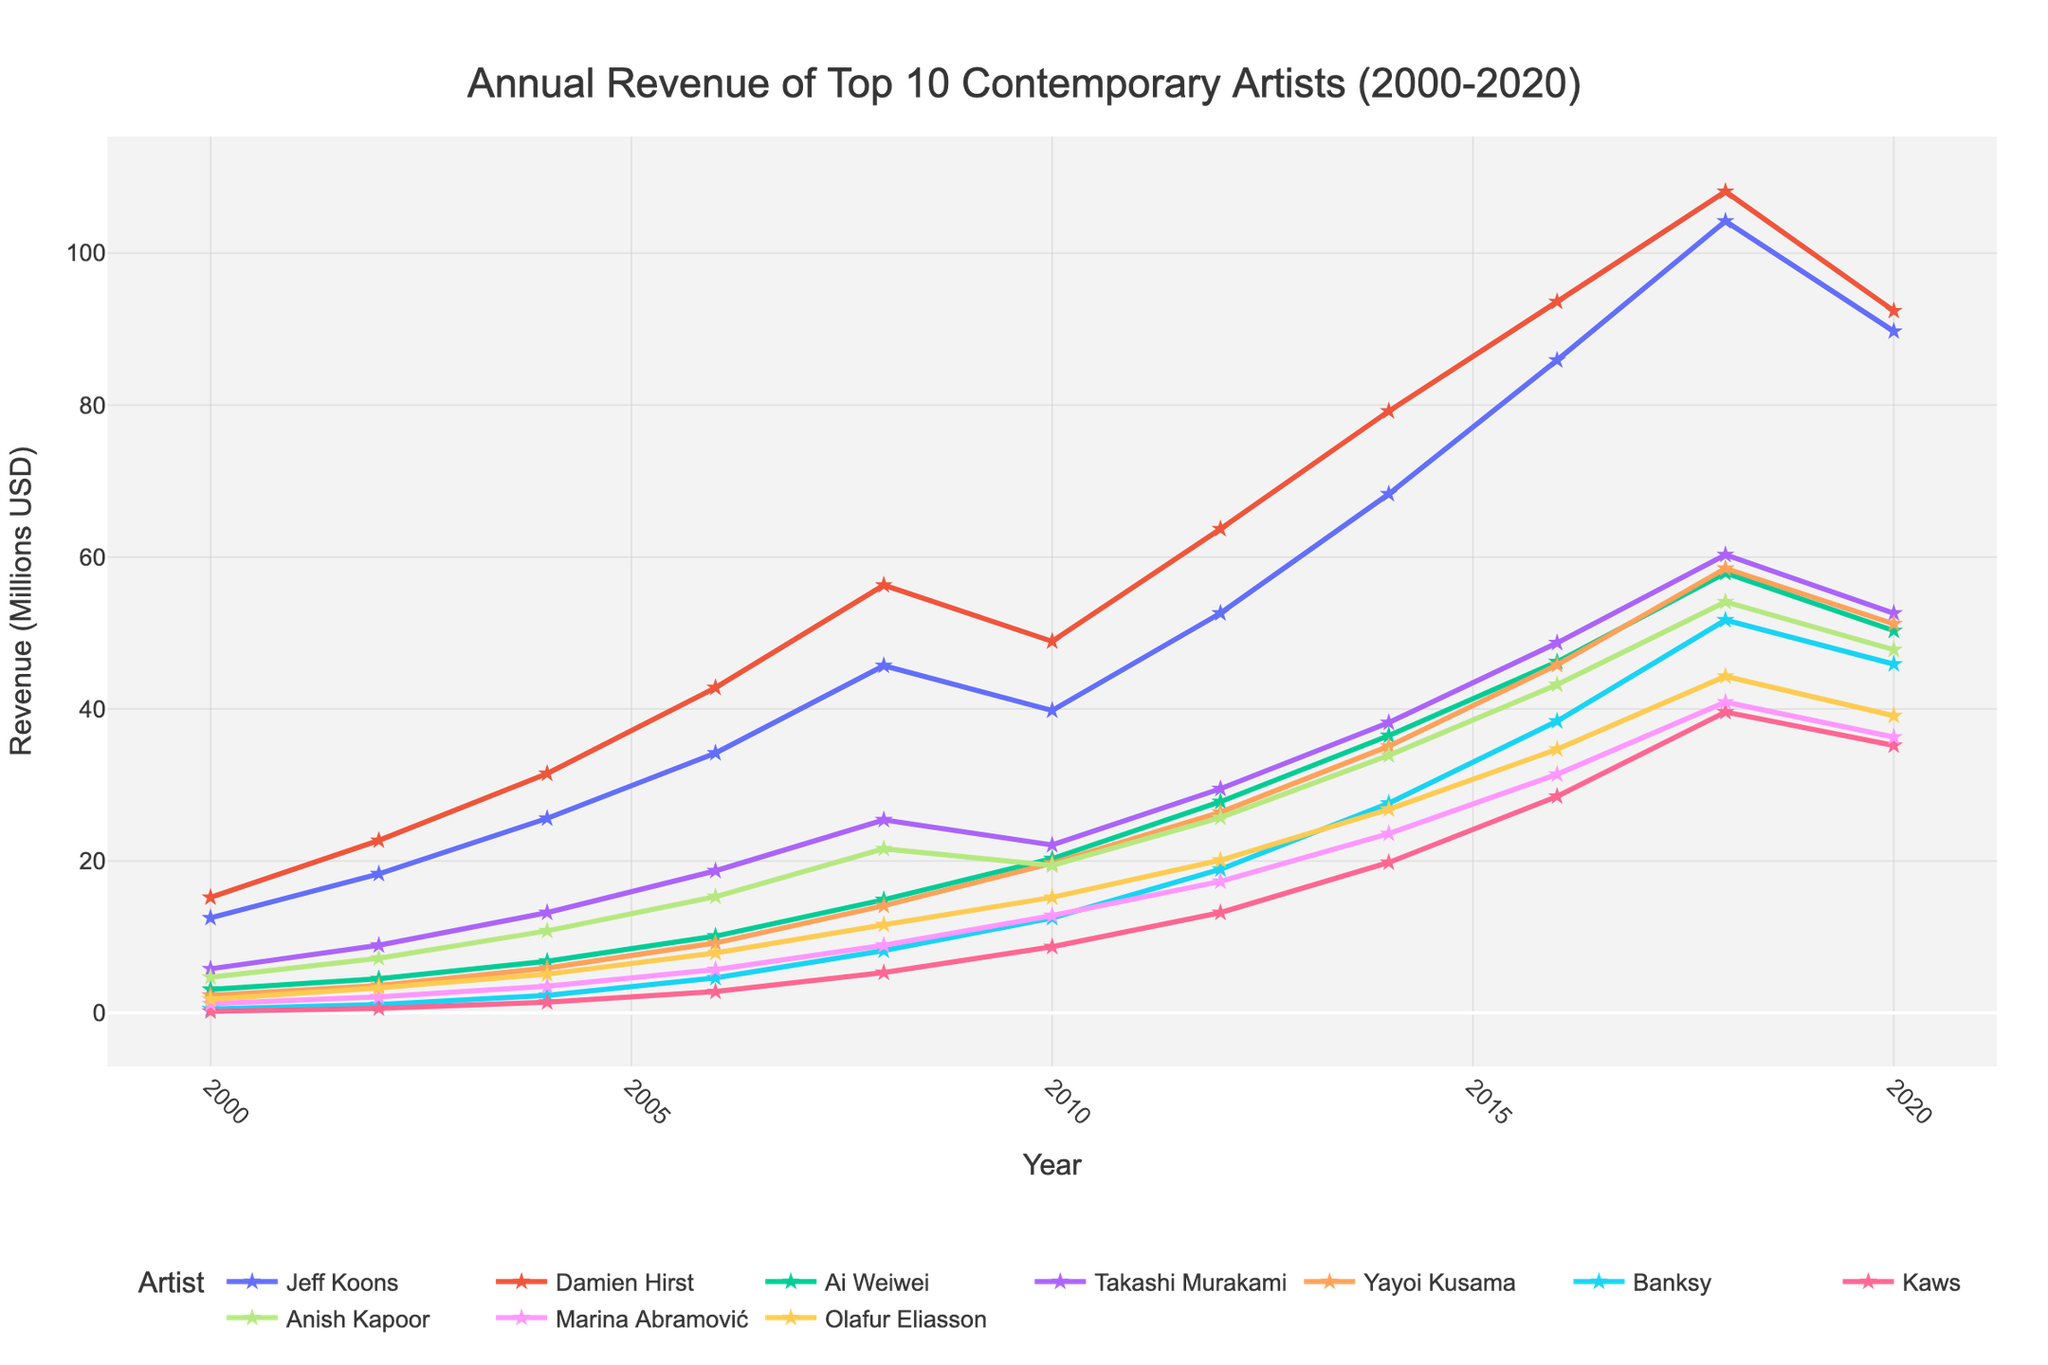What was the revenue difference between Jeff Koons and Ai Weiwei in 2010? To find the revenue difference, subtract Ai Weiwei's revenue from Jeff Koons' revenue in 2010: 39.8 (Jeff Koons) - 20.3 (Ai Weiwei).
Answer: 19.5 Which artist had the highest revenue in 2018? By comparing the revenue of each artist in 2018, it is observed that Jeff Koons had the highest revenue with 104.2 million USD.
Answer: Jeff Koons What is the average annual revenue of Marina Abramović from 2000 to 2020? Add all of Marina Abramović's annual revenues from 2000 to 2020, then divide by the number of years (11 entries): (1.2 + 2.1 + 3.5 + 5.7 + 8.9 + 12.8 + 17.3 + 23.6 + 31.4 + 40.9 + 36.3) / 11.
Answer: 17.1 In which year did Banksy surpass 10 million USD in revenue for the first time? By examining Banksy's revenue over the years, it is seen that in 2010, his revenue surpassed 10 million USD for the first time, reaching 12.5 million USD.
Answer: 2010 Did any artist experience a decrease in revenue from 2018 to 2020? If so, who? By comparing the 2018 and 2020 revenues, Jeff Koons (104.2 to 89.7), Damien Hirst (108.1 to 92.4), Ai Weiwei (57.9 to 50.3), Takashi Murakami (60.3 to 52.6), Yayoi Kusama (58.5 to 51.2), Banksy (51.7 to 45.9), Kaws (39.6 to 35.2), Anish Kapoor (54.1 to 47.8), Marina Abramović (40.9 to 36.3), and Olafur Eliasson (44.3 to 39.1) all experienced a decrease.
Answer: Yes, all did How many artists had a revenue of more than 25 million USD in 2012? By examining the revenue of each artist in 2012, it is observed that six artists (Jeff Koons, Damien Hirst, Ai Weiwei, Takashi Murakami, Yayoi Kusama, and Banksy) had a revenue of more than 25 million USD.
Answer: 6 Which artist had the smallest revenue in 2004? By comparing each artist's revenue in 2004, it is seen that Kaws had the smallest revenue at 1.4 million USD.
Answer: Kaws How much did Anish Kapoor's revenue increase from 2004 to 2008? Subtract Anish Kapoor's revenue in 2004 from his revenue in 2008: 21.6 (2008) - 10.8 (2004).
Answer: 10.8 Who had higher revenue in 2020, Olafur Eliasson or Yayoi Kusama? By comparing their revenues in 2020, Olafur Eliasson (39.1 million USD) had higher revenue than Yayoi Kusama (51.2 million USD).
Answer: Yayoi Kusama Which artist had the fastest growing revenue from 2000 to 2004? Calculate the growth rate over the years for each artist. Jeff Koons increased from 12.5 to 25.6 (13.1), Damien Hirst from 15.2 to 31.5 (16.3), Ai Weiwei from 3.1 to 6.8 (3.7), Takashi Murakami from 5.8 to 13.2 (7.4), Yayoi Kusama from 2.3 to 5.9 (3.6), Banksy from 0.5 to 2.3 (1.8), Kaws from 0.2 to 1.4 (1.2), Anish Kapoor from 4.7 to 10.8 (6.1), Marina Abramović from 1.2 to 3.5 (2.3), Olafur Eliasson from 1.8 to 5.1 (3.3). Damien Hirst had the highest absolute increase.
Answer: Damien Hirst 